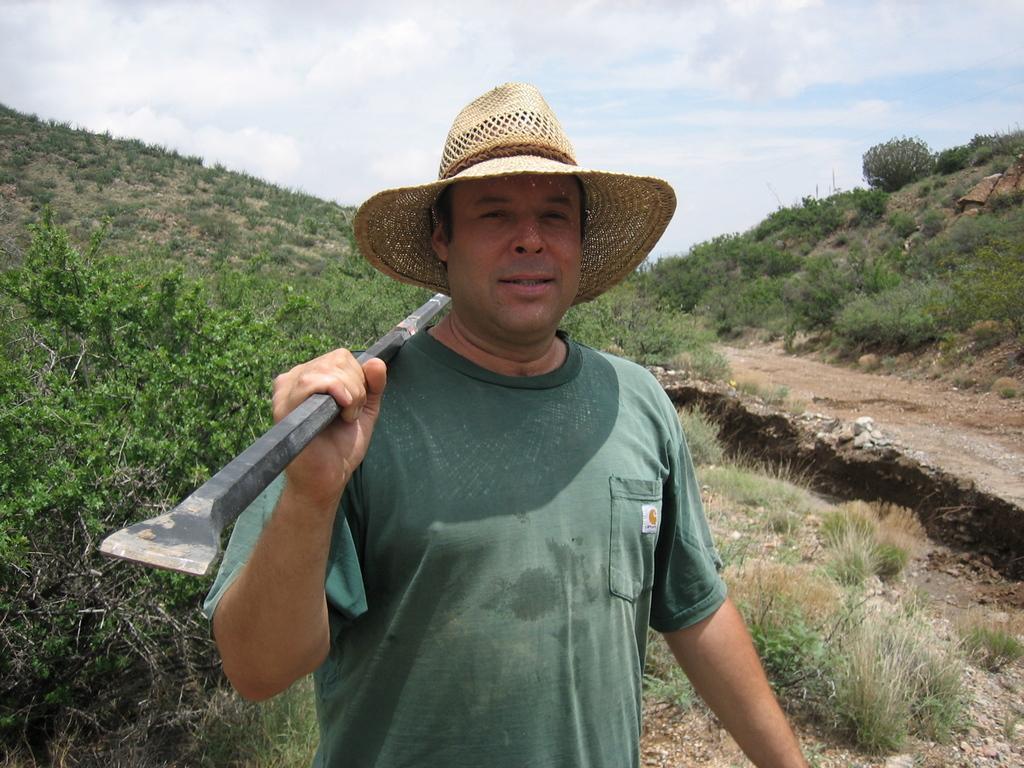Please provide a concise description of this image. In this image, we can see a person wearing a hat and holding a tool with his hand. There are some plants on the left side of the image. In the background of the image, there is a hill and sky. 